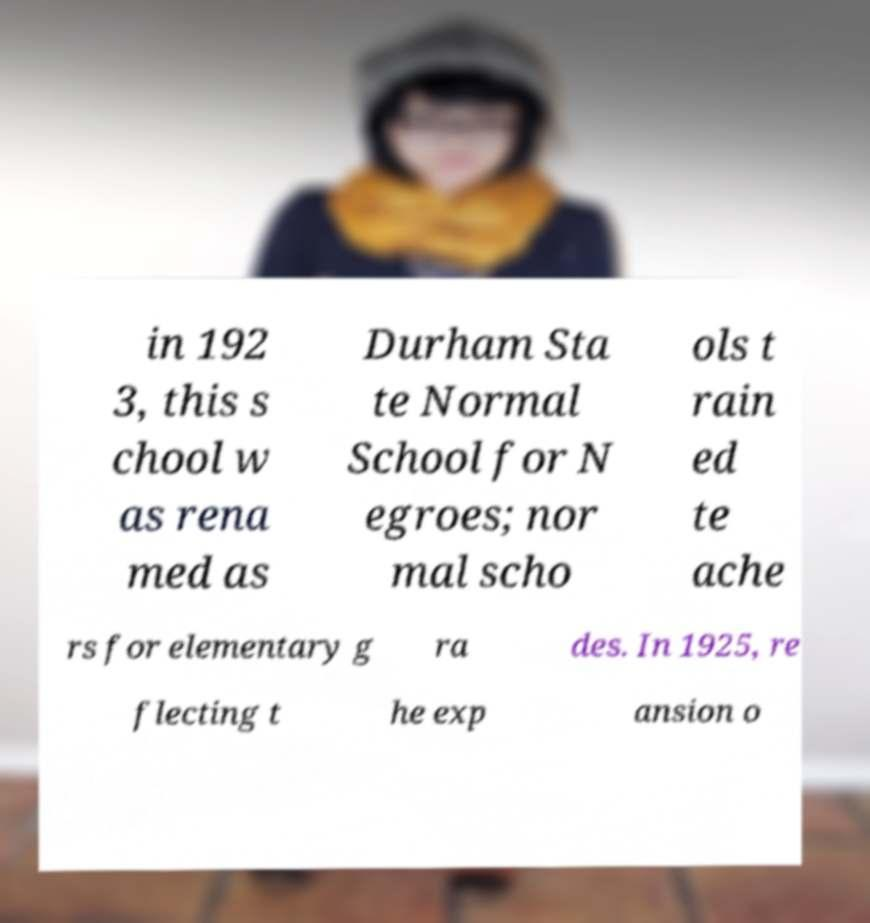For documentation purposes, I need the text within this image transcribed. Could you provide that? in 192 3, this s chool w as rena med as Durham Sta te Normal School for N egroes; nor mal scho ols t rain ed te ache rs for elementary g ra des. In 1925, re flecting t he exp ansion o 